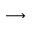<formula> <loc_0><loc_0><loc_500><loc_500>\longrightarrow</formula> 